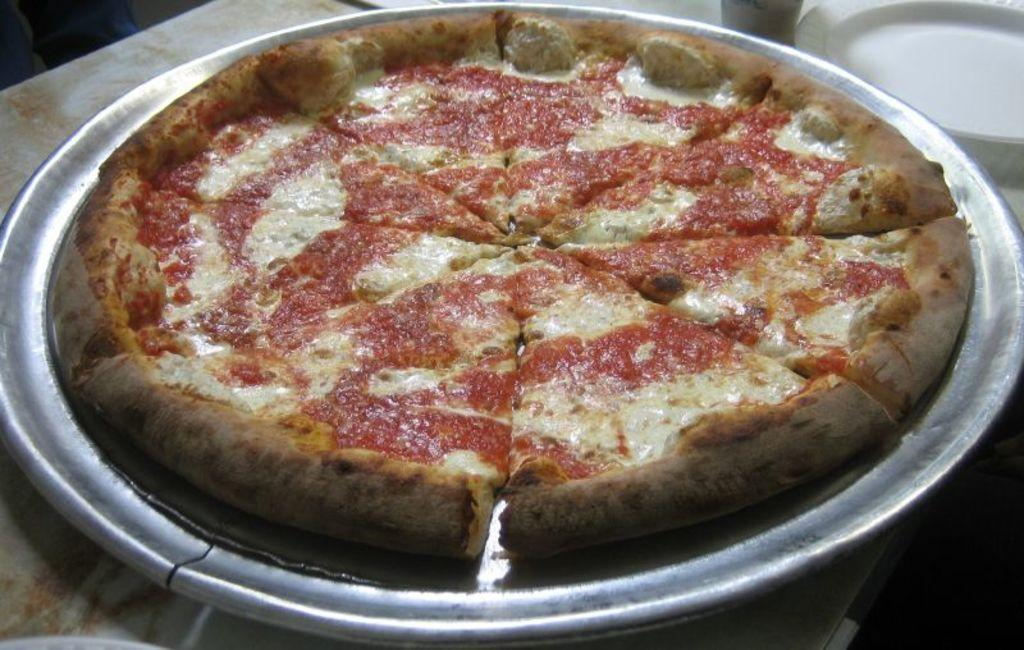What is on the plate that is visible in the image? There is food on a plate in the image. Where is the plate located in the image? The plate is on a surface in the image. Can you describe the plate on the top right side of the image? There is a white plate on the top right side of the image. How many rings does the person in the image have on their fingers? There is no person visible in the image, so it is not possible to determine how many rings they might be wearing. 